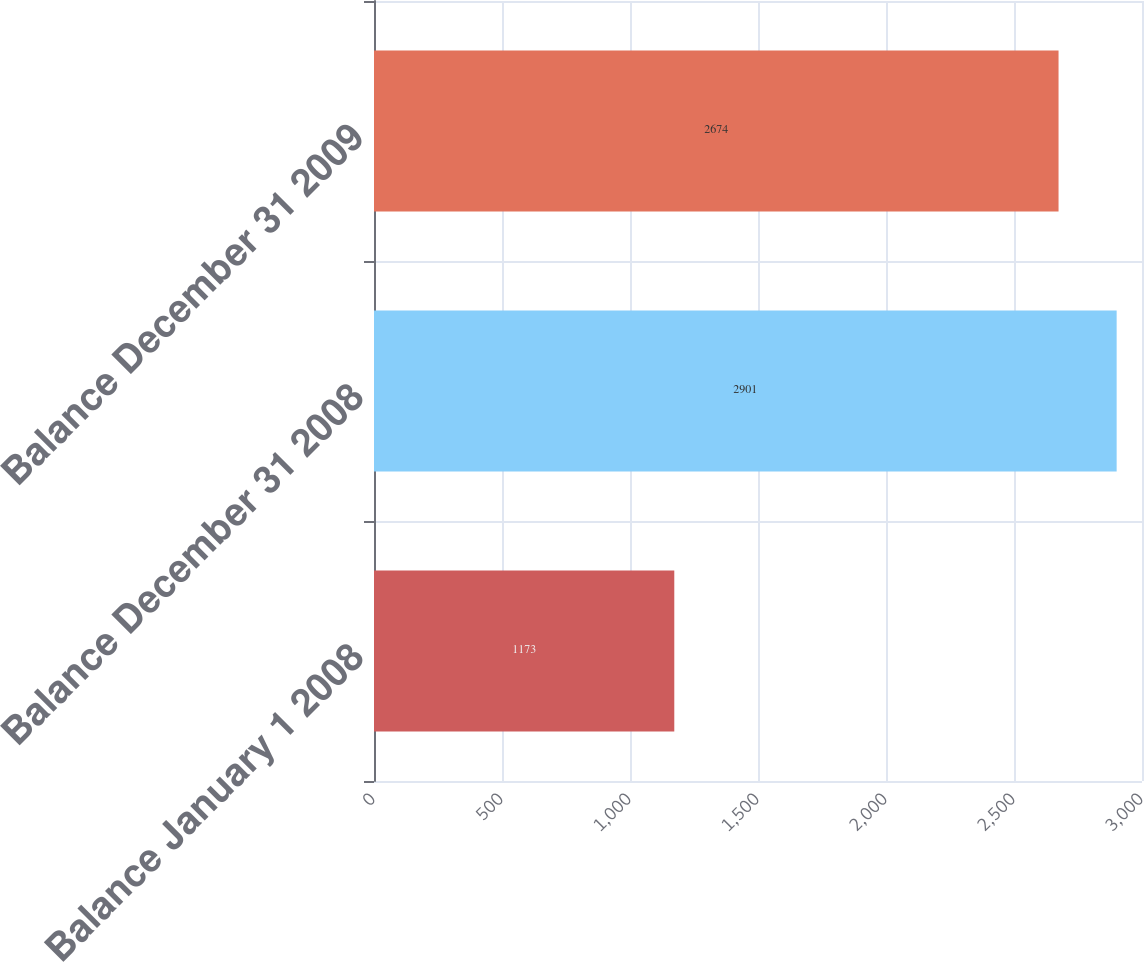Convert chart. <chart><loc_0><loc_0><loc_500><loc_500><bar_chart><fcel>Balance January 1 2008<fcel>Balance December 31 2008<fcel>Balance December 31 2009<nl><fcel>1173<fcel>2901<fcel>2674<nl></chart> 